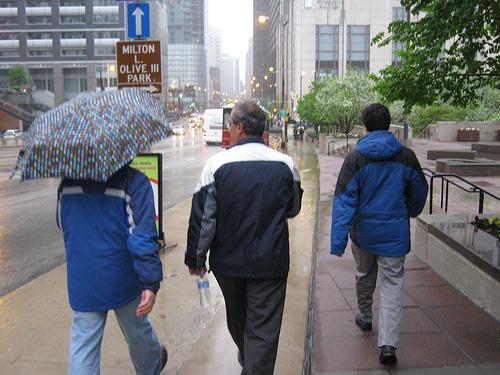How many men are in the picture?
Give a very brief answer. 3. 